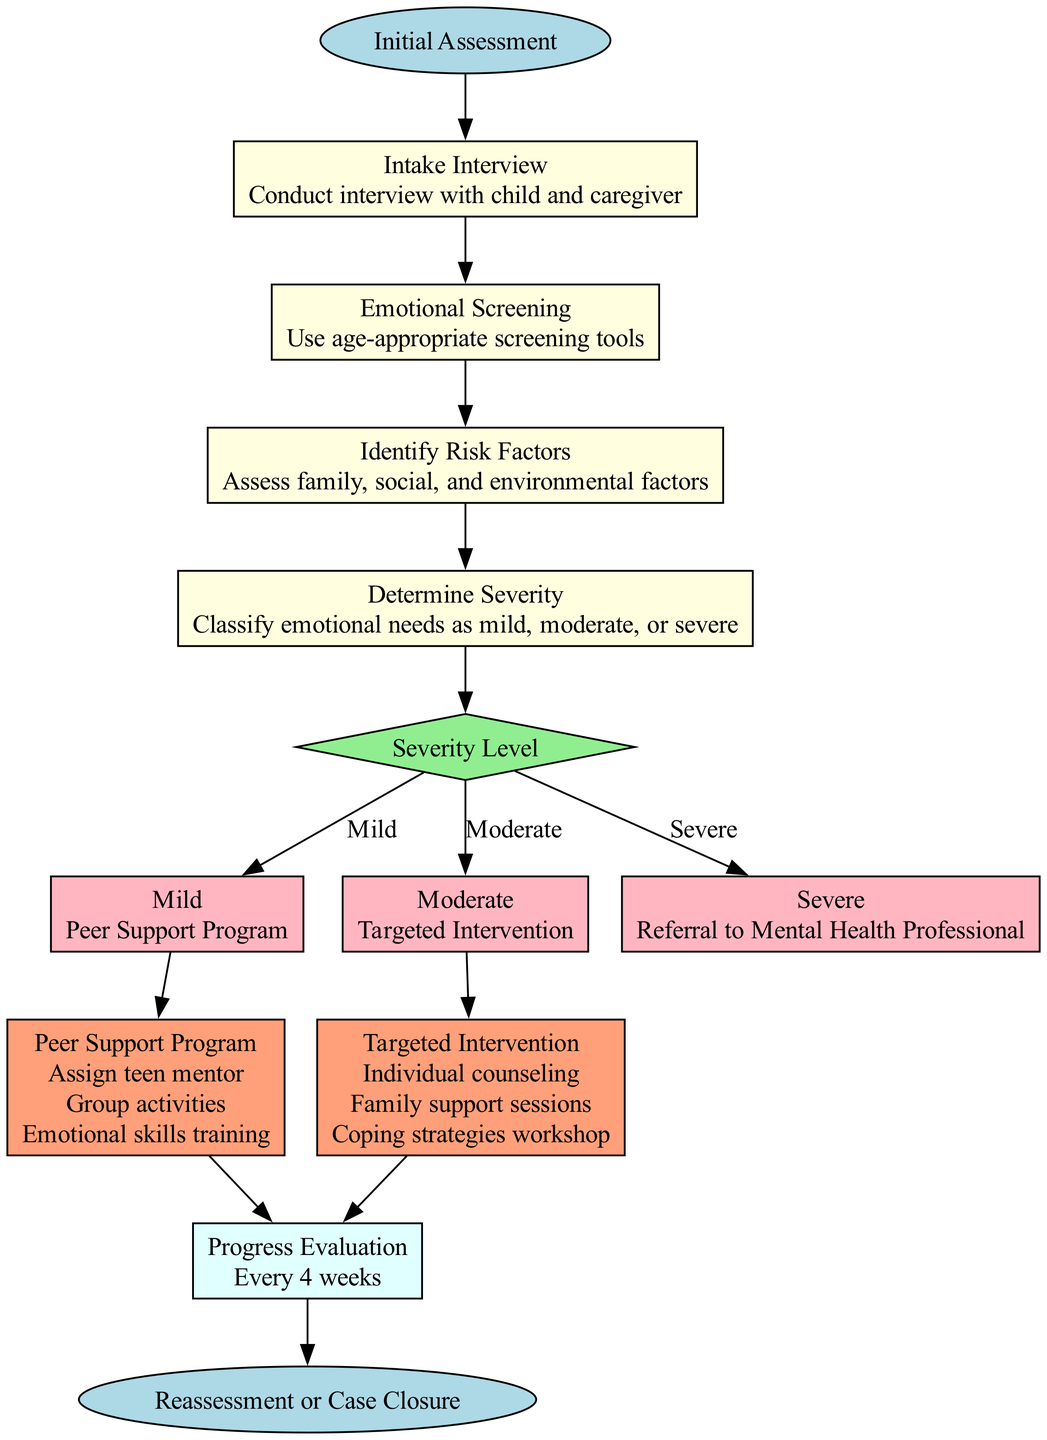What is the first step of the pathway? The diagram indicates the first step is labeled as "Initial Assessment," which serves as the starting point for the clinical pathway.
Answer: Initial Assessment How many steps are there in the clinical pathway? The overall flow consists of four sequential steps before reaching the decision point, contributing to the entirety of the pathway.
Answer: 4 What action is taken if the severity level is moderate? According to the decision options, if the severity level is assessed as moderate, the specified action is "Targeted Intervention."
Answer: Targeted Intervention What types of activities are included in the Peer Support Program? The diagram lists three activities relevant to the Peer Support Program: "Assign teen mentor," "Group activities," and "Emotional skills training," indicating its components.
Answer: Assign teen mentor, Group activities, Emotional skills training What is the frequency of the Progress Evaluation follow-up? The diagram specifies that the Progress Evaluation follow-up occurs every 4 weeks, establishing a clear timeline for reassessment.
Answer: Every 4 weeks What happens after the follow-up evaluation? Following the Progress Evaluation, the pathway concludes with either a "Reassessment" or "Case Closure," determining the next steps based on the child’s progress.
Answer: Reassessment or Case Closure What is the decision point condition in the pathway? The condition outlined in the decision node is "Severity Level," determining the appropriate actions to take based on the child’s emotional needs assessment.
Answer: Severity Level What intervention is associated with severe emotional needs? The diagram specifies that if the emotional needs are assessed as severe, the appropriate action is to make a "Referral to Mental Health Professional."
Answer: Referral to Mental Health Professional How does the Peer Support Program connect to the clinical pathway? The Peer Support Program follows the decision node after identifying a mild severity level, indicating it as the corresponding intervention in that scenario.
Answer: Peer Support Program 